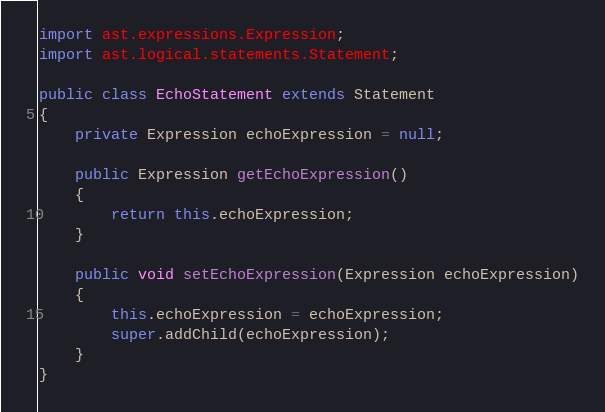Convert code to text. <code><loc_0><loc_0><loc_500><loc_500><_Java_>import ast.expressions.Expression;
import ast.logical.statements.Statement;

public class EchoStatement extends Statement
{
	private Expression echoExpression = null;

	public Expression getEchoExpression()
	{
		return this.echoExpression;
	}

	public void setEchoExpression(Expression echoExpression)
	{
		this.echoExpression = echoExpression;
		super.addChild(echoExpression);
	}
}
</code> 